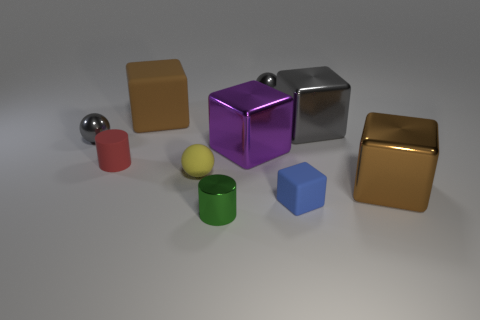Subtract all gray balls. How many balls are left? 1 Subtract all brown blocks. How many blocks are left? 3 Subtract all purple cylinders. How many gray spheres are left? 2 Subtract all cylinders. How many objects are left? 8 Subtract 2 cylinders. How many cylinders are left? 0 Subtract 0 blue balls. How many objects are left? 10 Subtract all cyan blocks. Subtract all gray cylinders. How many blocks are left? 5 Subtract all blue rubber things. Subtract all brown blocks. How many objects are left? 7 Add 5 tiny metal spheres. How many tiny metal spheres are left? 7 Add 5 red rubber cylinders. How many red rubber cylinders exist? 6 